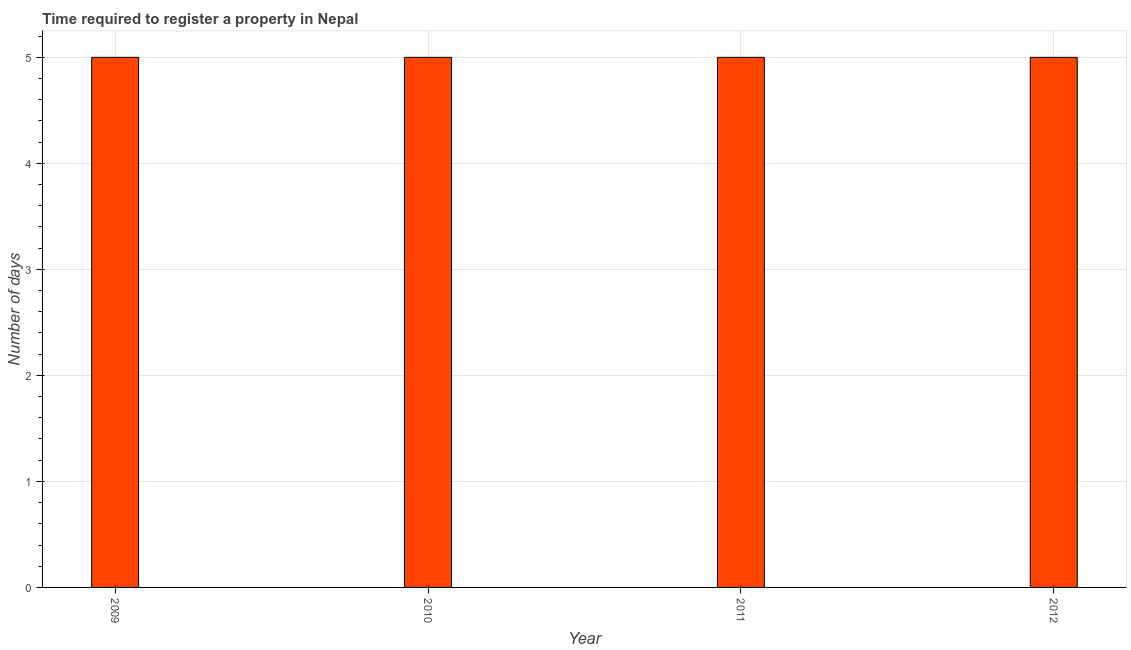Does the graph contain any zero values?
Keep it short and to the point. No. Does the graph contain grids?
Provide a succinct answer. Yes. What is the title of the graph?
Ensure brevity in your answer.  Time required to register a property in Nepal. What is the label or title of the X-axis?
Keep it short and to the point. Year. What is the label or title of the Y-axis?
Your response must be concise. Number of days. In which year was the number of days required to register property maximum?
Provide a short and direct response. 2009. In which year was the number of days required to register property minimum?
Offer a terse response. 2009. What is the sum of the number of days required to register property?
Your response must be concise. 20. What is the difference between the number of days required to register property in 2009 and 2012?
Provide a succinct answer. 0. What is the average number of days required to register property per year?
Make the answer very short. 5. What is the median number of days required to register property?
Ensure brevity in your answer.  5. What is the ratio of the number of days required to register property in 2011 to that in 2012?
Keep it short and to the point. 1. Is the number of days required to register property in 2010 less than that in 2012?
Offer a terse response. No. Is the difference between the number of days required to register property in 2010 and 2011 greater than the difference between any two years?
Your answer should be very brief. Yes. Is the sum of the number of days required to register property in 2011 and 2012 greater than the maximum number of days required to register property across all years?
Your answer should be very brief. Yes. What is the difference between the highest and the lowest number of days required to register property?
Your response must be concise. 0. In how many years, is the number of days required to register property greater than the average number of days required to register property taken over all years?
Make the answer very short. 0. How many years are there in the graph?
Give a very brief answer. 4. What is the difference between two consecutive major ticks on the Y-axis?
Your answer should be very brief. 1. Are the values on the major ticks of Y-axis written in scientific E-notation?
Make the answer very short. No. What is the Number of days of 2011?
Your response must be concise. 5. What is the Number of days in 2012?
Offer a very short reply. 5. What is the difference between the Number of days in 2009 and 2011?
Give a very brief answer. 0. What is the difference between the Number of days in 2009 and 2012?
Make the answer very short. 0. What is the difference between the Number of days in 2010 and 2011?
Offer a very short reply. 0. What is the ratio of the Number of days in 2009 to that in 2011?
Give a very brief answer. 1. What is the ratio of the Number of days in 2010 to that in 2011?
Make the answer very short. 1. What is the ratio of the Number of days in 2010 to that in 2012?
Ensure brevity in your answer.  1. What is the ratio of the Number of days in 2011 to that in 2012?
Make the answer very short. 1. 